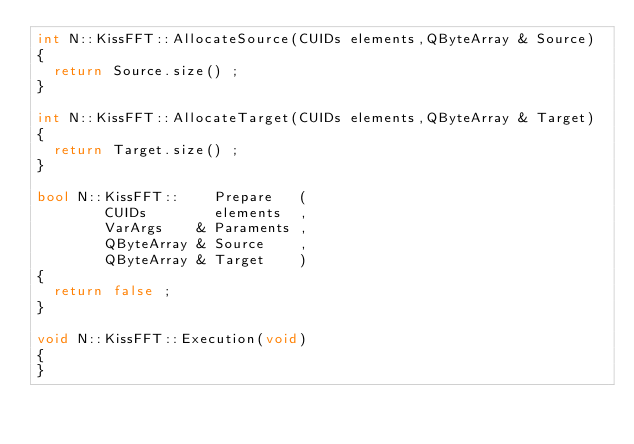<code> <loc_0><loc_0><loc_500><loc_500><_C++_>int N::KissFFT::AllocateSource(CUIDs elements,QByteArray & Source)
{
  return Source.size() ;
}

int N::KissFFT::AllocateTarget(CUIDs elements,QByteArray & Target)
{
  return Target.size() ;
}

bool N::KissFFT::    Prepare   (
        CUIDs        elements  ,
        VarArgs    & Paraments ,
        QByteArray & Source    ,
        QByteArray & Target    )
{
  return false ;
}

void N::KissFFT::Execution(void)
{
}
</code> 